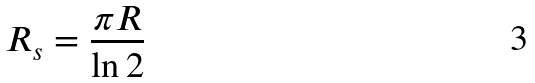<formula> <loc_0><loc_0><loc_500><loc_500>R _ { s } = \frac { \pi R } { \ln 2 }</formula> 